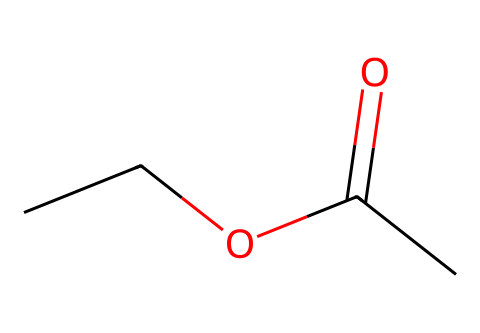What is the molecular formula of this compound? The molecular formula can be determined from the SMILES representation by counting the number of carbon (C), hydrogen (H), and oxygen (O) atoms present. From the structure, there are 4 carbon atoms, 8 hydrogen atoms, and 2 oxygen atoms, leading to the formula C4H8O2.
Answer: C4H8O2 How many carbon atoms are in ethyl acetate? By analyzing the SMILES notation, each "C" represents a carbon atom. There are 4 "C" characters in the structure, indicating the presence of 4 carbon atoms.
Answer: 4 What type of functional group does ethyl acetate belong to? The presence of the carbonyl group (C=O) and the ester bond (C-O-C) indicates that ethyl acetate is an ester. This can be concluded by noting the arrangement of atoms in the molecule.
Answer: ester What is the total number of hydrogen atoms in this molecule? By counting the number of hydrogen atoms represented in the SMILES, we can see that there are 8 hydrogen atoms attached as part of the carbon chains and groups.
Answer: 8 Which atoms in this molecule might contribute to its characteristic fruity odor? The presence of the carbonyl group (C=O) along with the alkyl groups (ethyl part of the molecule) signifies that this compound is likely to have a fruity odor typical of esters. The ester functional group is generally associated with fruity scents.
Answer: ester functional group What is the role of ethyl acetate in book preservation? Ethyl acetate is often used as a solvent due to its ability to dissolve certain plastics and adhesives in book preservation, making it easier to repair old books without causing damage. This role can be inferred based on its solvent properties and low toxicity.
Answer: solvent Is ethyl acetate polar or non-polar? Ethyl acetate has a polar carbonyl group (C=O) but also has non-polar alkyl components, meaning it can exhibit both polar and non-polar characteristics, with a slight overall polarity due to its functional group.
Answer: polar 